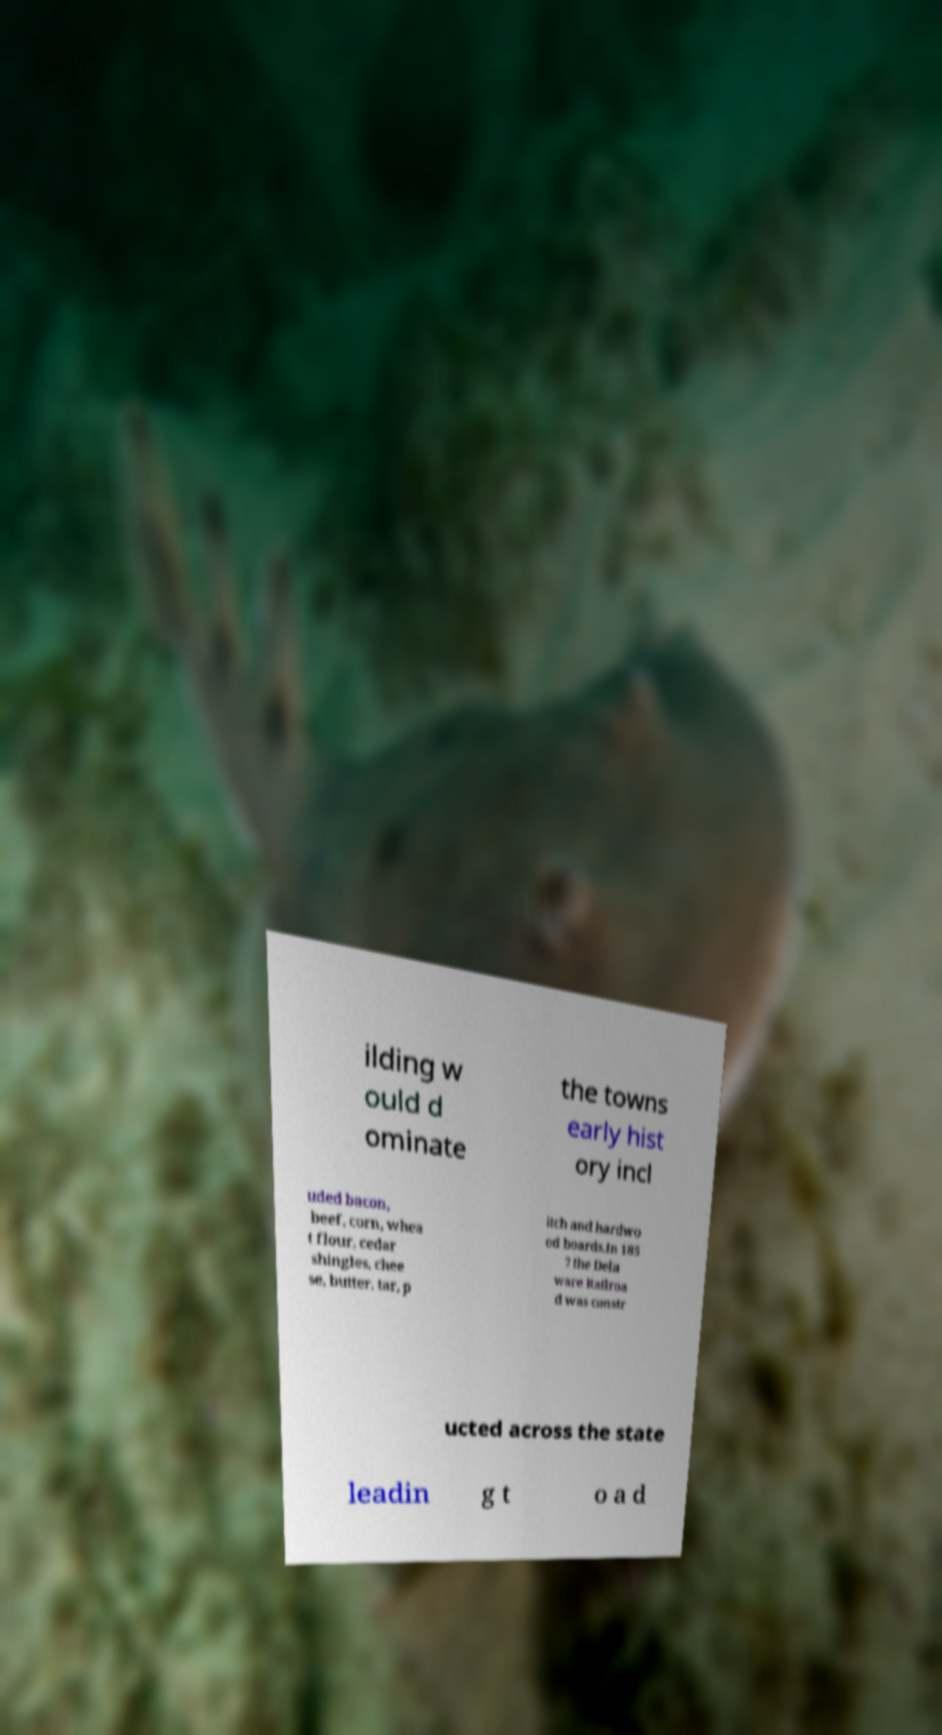Please read and relay the text visible in this image. What does it say? ilding w ould d ominate the towns early hist ory incl uded bacon, beef, corn, whea t flour, cedar shingles, chee se, butter, tar, p itch and hardwo od boards.In 185 7 the Dela ware Railroa d was constr ucted across the state leadin g t o a d 